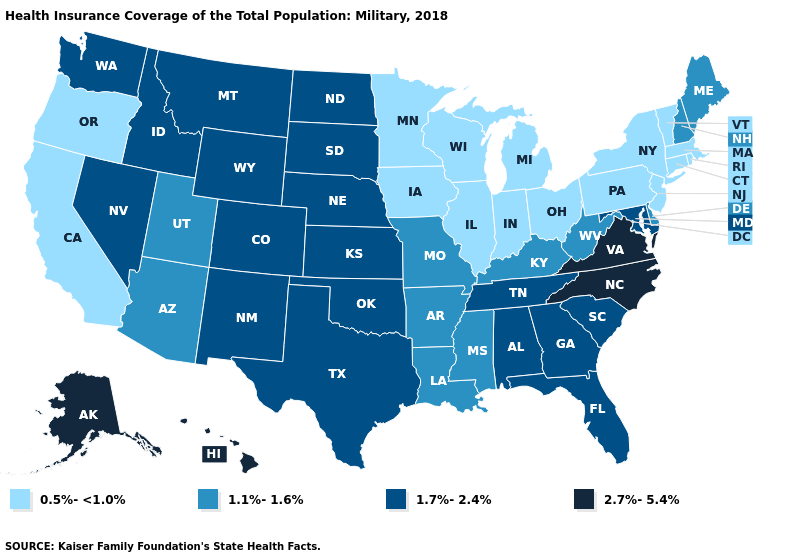What is the lowest value in states that border South Dakota?
Write a very short answer. 0.5%-<1.0%. Name the states that have a value in the range 0.5%-<1.0%?
Be succinct. California, Connecticut, Illinois, Indiana, Iowa, Massachusetts, Michigan, Minnesota, New Jersey, New York, Ohio, Oregon, Pennsylvania, Rhode Island, Vermont, Wisconsin. Name the states that have a value in the range 2.7%-5.4%?
Keep it brief. Alaska, Hawaii, North Carolina, Virginia. Name the states that have a value in the range 2.7%-5.4%?
Be succinct. Alaska, Hawaii, North Carolina, Virginia. What is the highest value in the Northeast ?
Write a very short answer. 1.1%-1.6%. What is the value of Michigan?
Answer briefly. 0.5%-<1.0%. What is the lowest value in the West?
Answer briefly. 0.5%-<1.0%. Does New Mexico have the lowest value in the USA?
Concise answer only. No. Which states have the highest value in the USA?
Concise answer only. Alaska, Hawaii, North Carolina, Virginia. Name the states that have a value in the range 1.7%-2.4%?
Answer briefly. Alabama, Colorado, Florida, Georgia, Idaho, Kansas, Maryland, Montana, Nebraska, Nevada, New Mexico, North Dakota, Oklahoma, South Carolina, South Dakota, Tennessee, Texas, Washington, Wyoming. Which states have the highest value in the USA?
Concise answer only. Alaska, Hawaii, North Carolina, Virginia. Does the map have missing data?
Write a very short answer. No. What is the highest value in the MidWest ?
Short answer required. 1.7%-2.4%. Name the states that have a value in the range 2.7%-5.4%?
Give a very brief answer. Alaska, Hawaii, North Carolina, Virginia. 